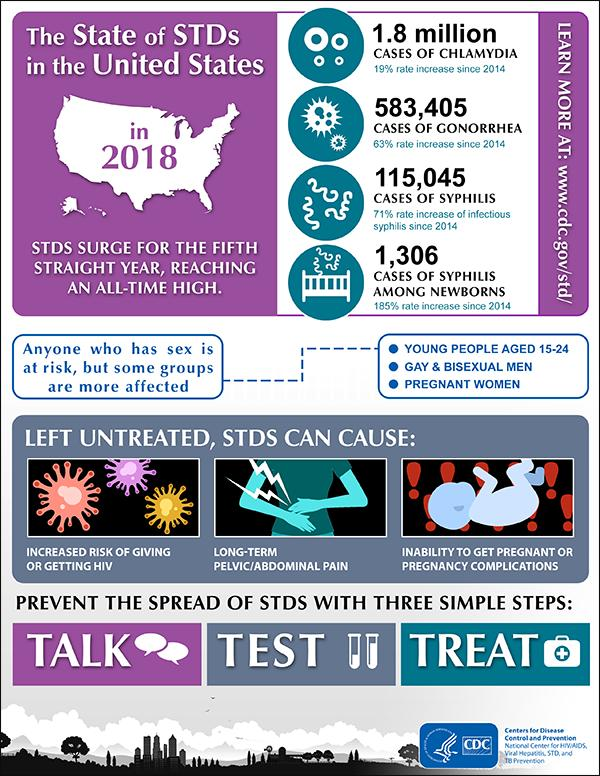Highlight a few significant elements in this photo. Testing is the second step that helps in curbing sexually transmitted diseases. The first step in preventing the outbreak of sexually transmitted diseases is to talk openly and honestly about sexual activity and practices with one's partners. The third step that helps in controlling STDs is treatment. 